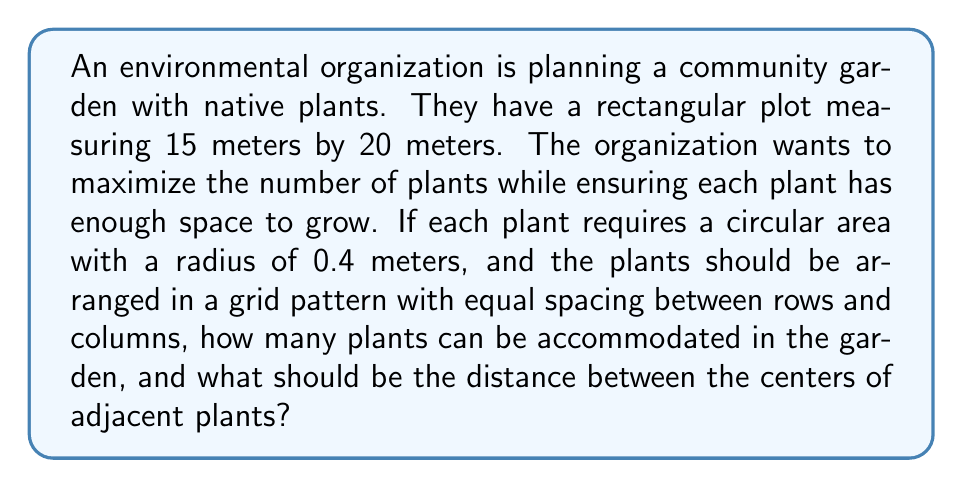Show me your answer to this math problem. To solve this problem, we need to follow these steps:

1. Calculate the area each plant requires:
   The area of a circle is given by $A = \pi r^2$
   $$A = \pi (0.4\text{m})^2 = 0.5027\text{m}^2$$

2. Determine the spacing between plants:
   Let $x$ be the distance between centers of adjacent plants.
   The area each plant occupies in the grid is $x^2$.
   We want $x^2$ to be slightly larger than the circular area:
   $$x^2 \approx 0.5027\text{m}^2$$
   $$x \approx \sqrt{0.5027} = 0.7089\text{m}$$
   Rounding up for practicality: $x = 0.71\text{m}$

3. Calculate the number of rows and columns:
   Number of rows = $\lfloor \frac{15\text{m}}{0.71\text{m}} \rfloor = 21$
   Number of columns = $\lfloor \frac{20\text{m}}{0.71\text{m}} \rfloor = 28$

4. Calculate the total number of plants:
   Total plants = Number of rows × Number of columns
   $$21 \times 28 = 588$$

Therefore, the garden can accommodate 588 plants with a spacing of 0.71 meters between the centers of adjacent plants.
Answer: The community garden can accommodate 588 plants with a spacing of 0.71 meters between the centers of adjacent plants. 